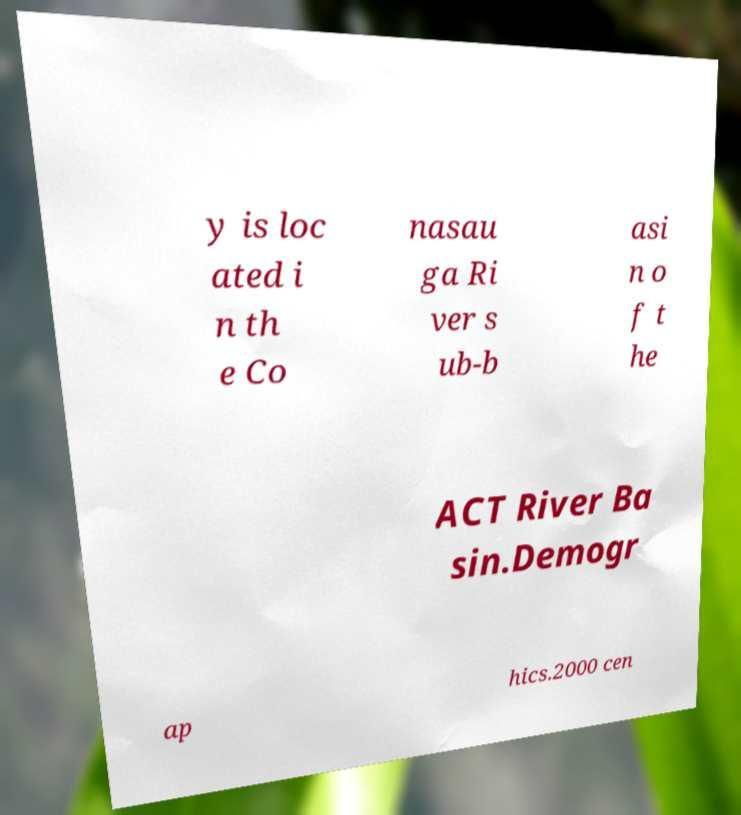I need the written content from this picture converted into text. Can you do that? y is loc ated i n th e Co nasau ga Ri ver s ub-b asi n o f t he ACT River Ba sin.Demogr ap hics.2000 cen 